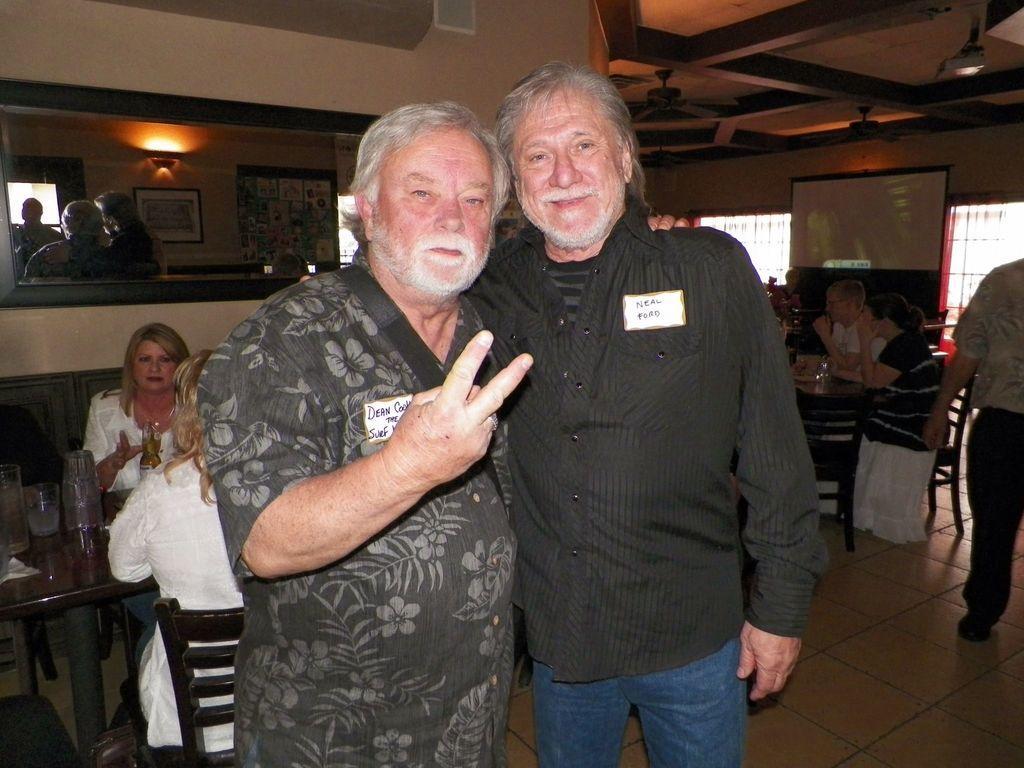In one or two sentences, can you explain what this image depicts? There are two persons standing and wearing badges. There are tables and chairs. Some people are sitting on chairs. On the table there is a glass and jars. In the back there's a wall. On the wall there is a mirror. On the mirror there are reflections of photo frames and light. On the right side there are windows. 